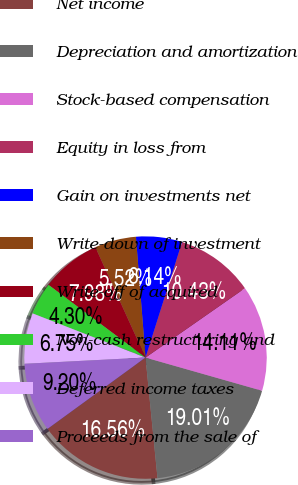Convert chart to OTSL. <chart><loc_0><loc_0><loc_500><loc_500><pie_chart><fcel>Net income<fcel>Depreciation and amortization<fcel>Stock-based compensation<fcel>Equity in loss from<fcel>Gain on investments net<fcel>Write-down of investment<fcel>Write-off of acquired<fcel>Non-cash restructuring and<fcel>Deferred income taxes<fcel>Proceeds from the sale of<nl><fcel>16.56%<fcel>19.01%<fcel>14.11%<fcel>10.43%<fcel>6.14%<fcel>5.52%<fcel>7.98%<fcel>4.3%<fcel>6.75%<fcel>9.2%<nl></chart> 